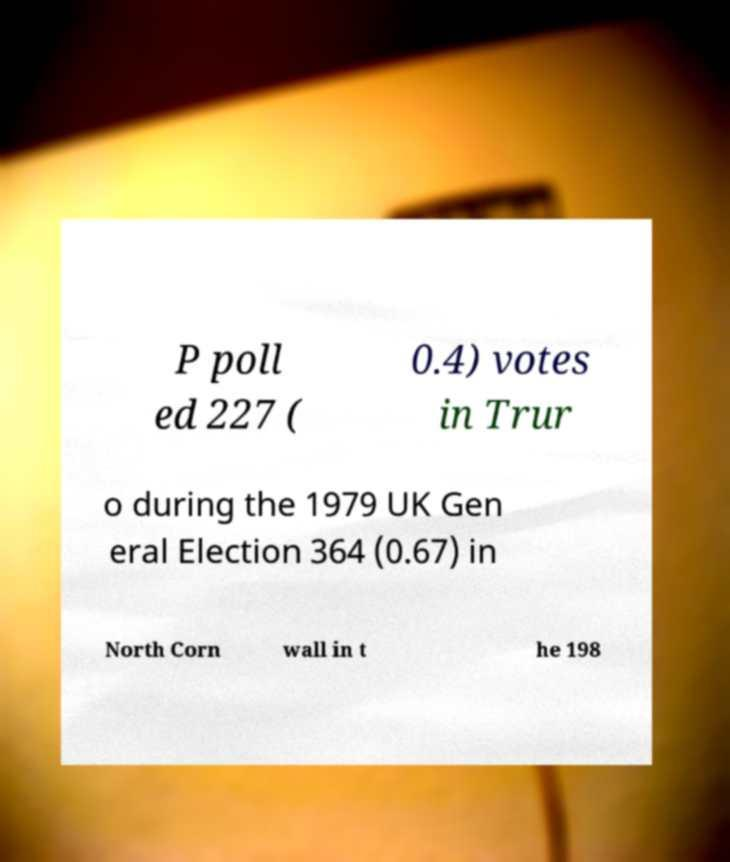I need the written content from this picture converted into text. Can you do that? P poll ed 227 ( 0.4) votes in Trur o during the 1979 UK Gen eral Election 364 (0.67) in North Corn wall in t he 198 